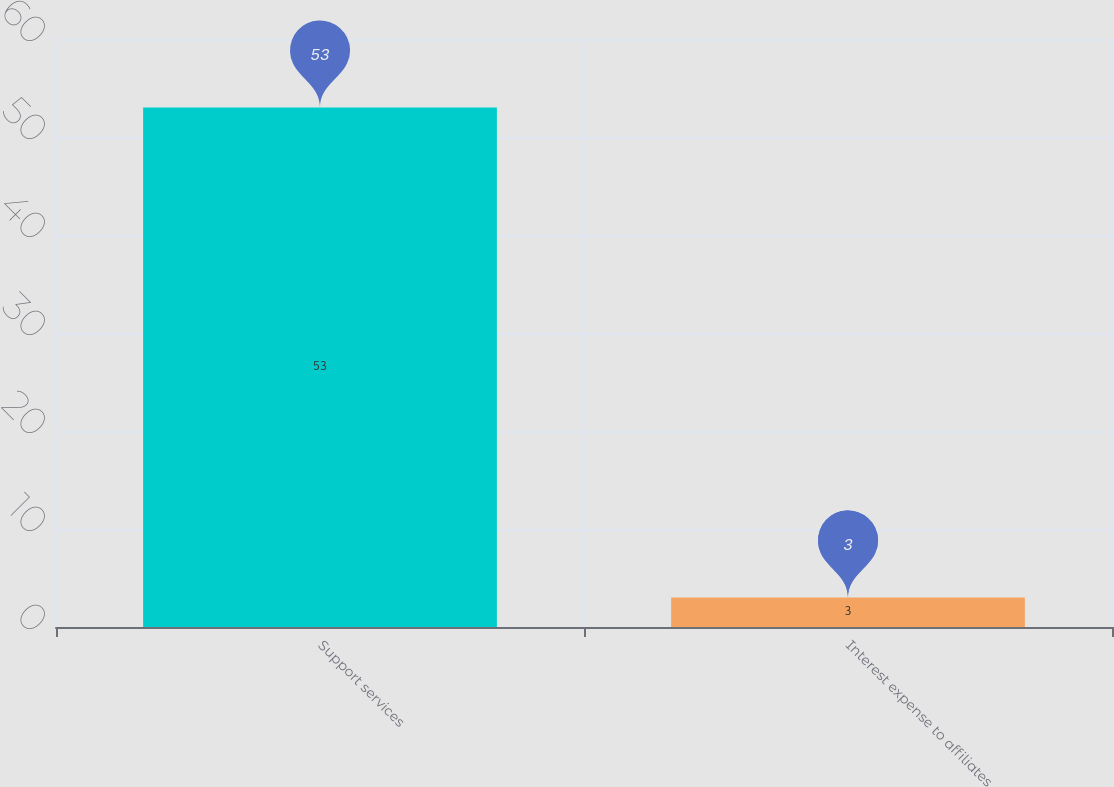<chart> <loc_0><loc_0><loc_500><loc_500><bar_chart><fcel>Support services<fcel>Interest expense to affiliates<nl><fcel>53<fcel>3<nl></chart> 